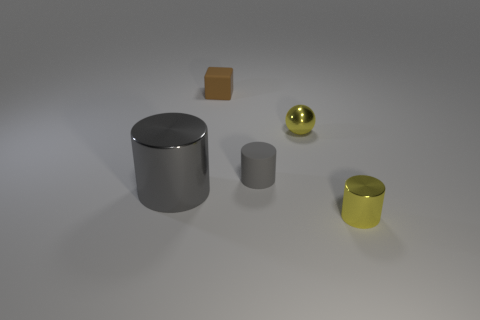What is the material of the thing that is the same color as the ball? The item that shares the same color as the gold-colored ball appears to be a small cylinder, and it looks like it's made of metal, potentially brass or a similar alloy, given its reflective surface and golden hue. 